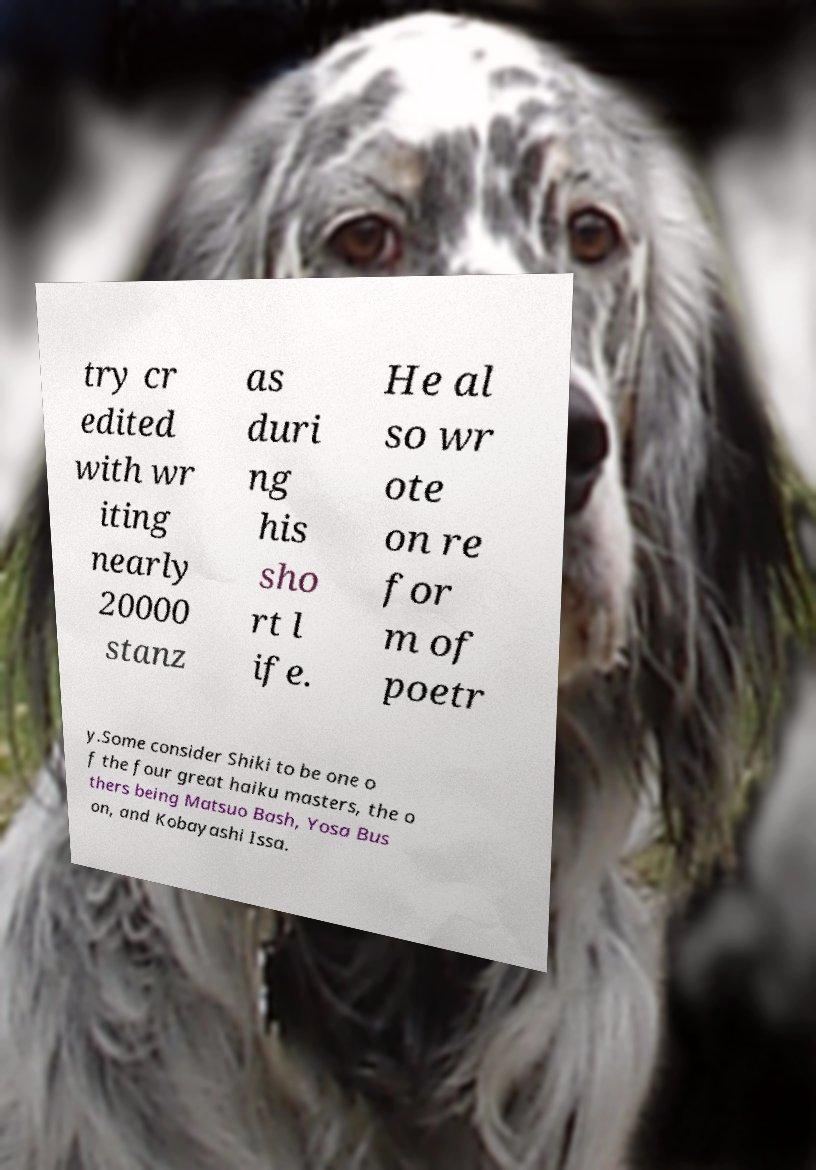What messages or text are displayed in this image? I need them in a readable, typed format. try cr edited with wr iting nearly 20000 stanz as duri ng his sho rt l ife. He al so wr ote on re for m of poetr y.Some consider Shiki to be one o f the four great haiku masters, the o thers being Matsuo Bash, Yosa Bus on, and Kobayashi Issa. 